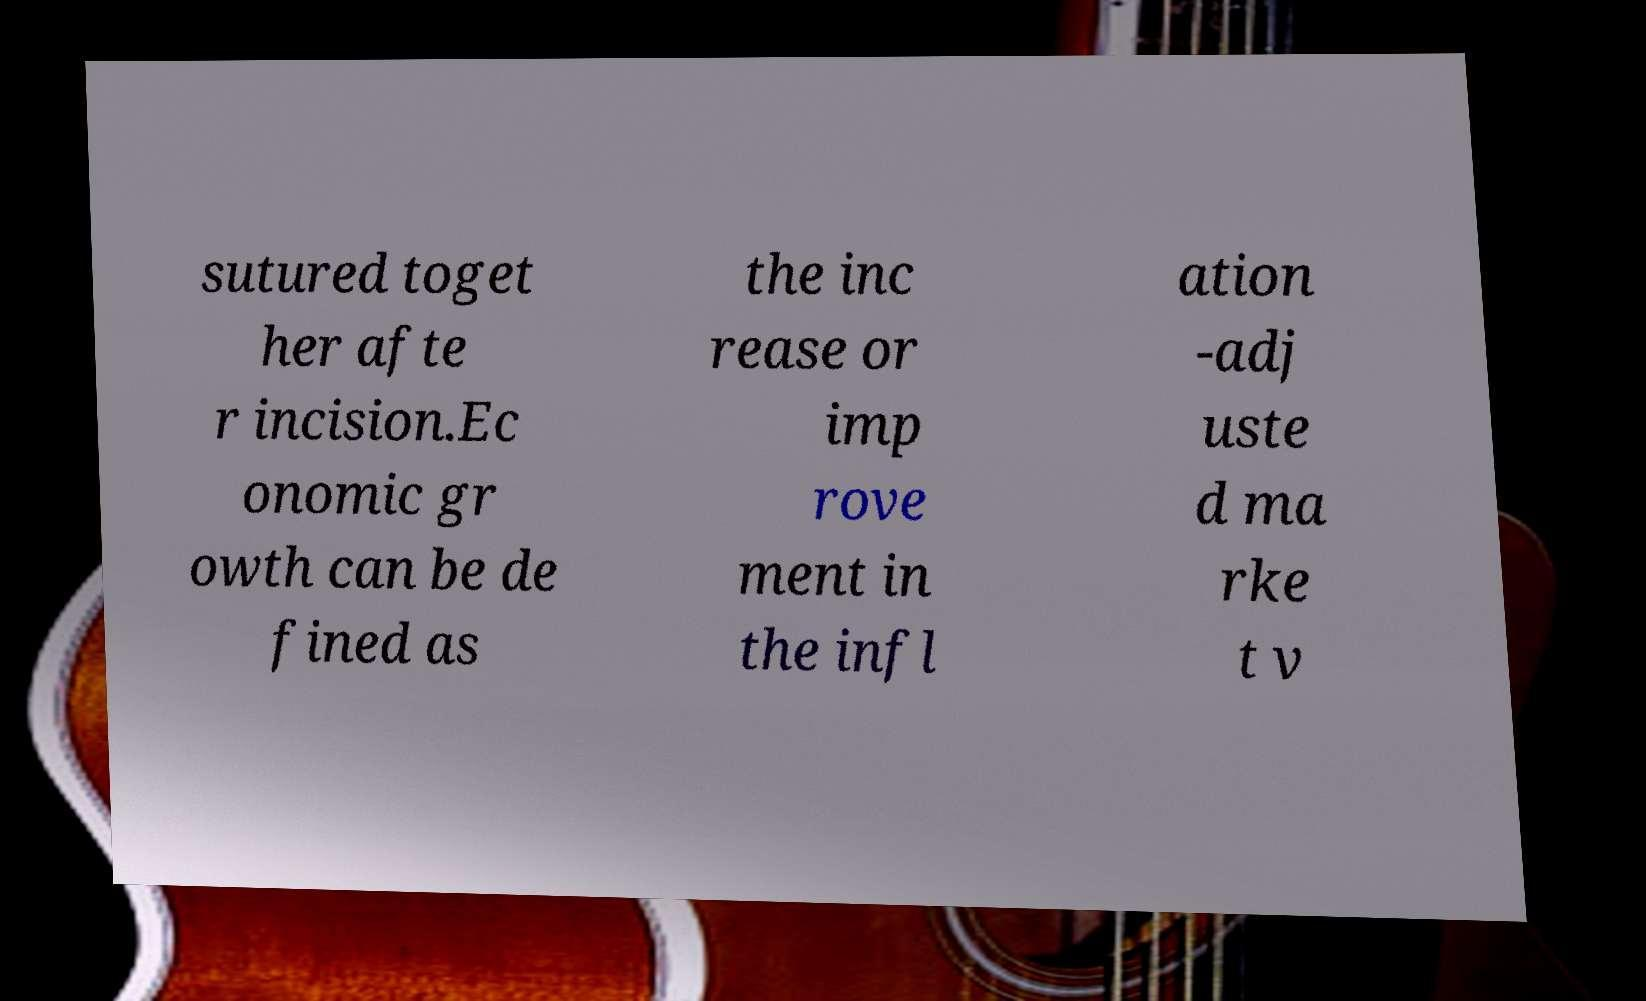For documentation purposes, I need the text within this image transcribed. Could you provide that? sutured toget her afte r incision.Ec onomic gr owth can be de fined as the inc rease or imp rove ment in the infl ation -adj uste d ma rke t v 